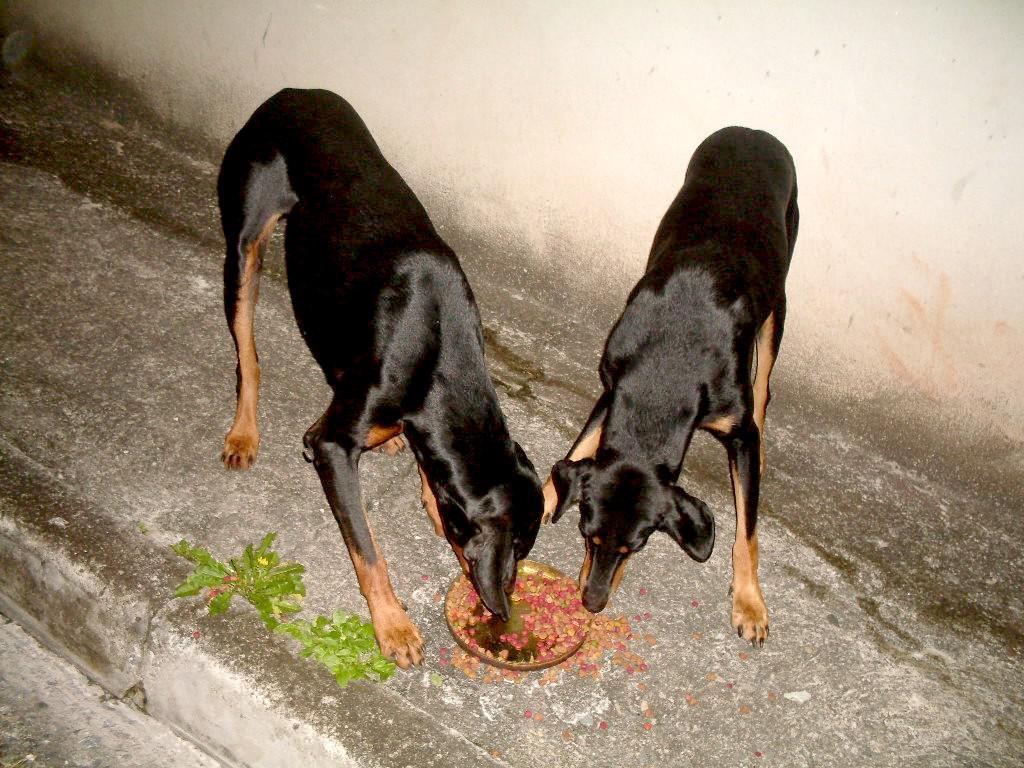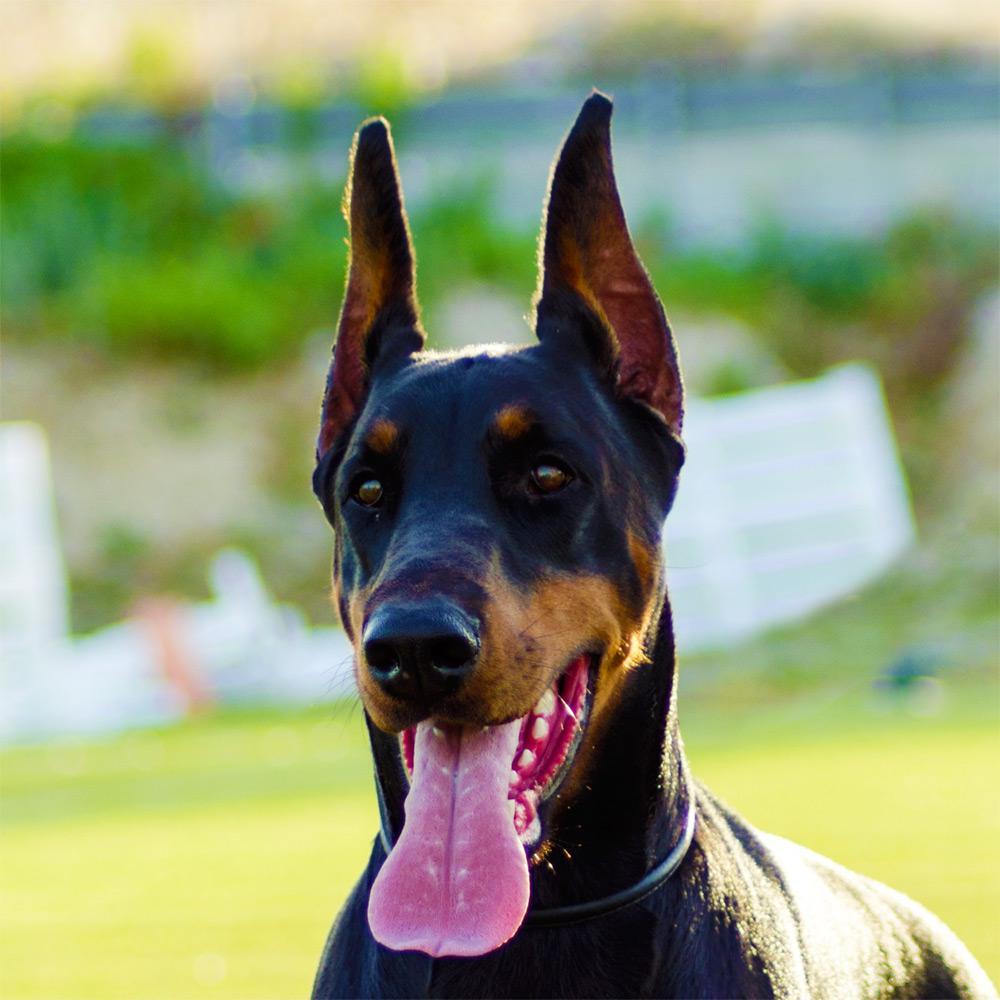The first image is the image on the left, the second image is the image on the right. For the images displayed, is the sentence "One image shows side-by-side dobermans with at least one having erect ears, and the other image shows one rightward-turned doberman with docked tail and erect pointy ears." factually correct? Answer yes or no. No. The first image is the image on the left, the second image is the image on the right. Given the left and right images, does the statement "At least one doberman has its tongue out." hold true? Answer yes or no. Yes. 